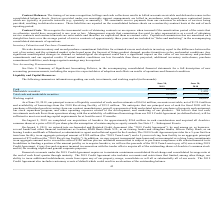From Extreme Networks's financial document, Which years does the table provide information for the company's cash, investments, and working capital? The document shows two values: 2019 and 2018. From the document: "2019 2018..." Also, What was the amount of cash in 2018? According to the financial document, 121,139 (in thousands). The relevant text states: "Cash $ 169,607 $ 121,139..." Also, What was the Total cash and marketable securities in 2019? According to the financial document, 169,607 (in thousands). The relevant text states: "Cash $ 169,607 $ 121,139..." Also, How many years did the amount of Cash exceed $100,000 thousand? Counting the relevant items in the document: 2019, 2018, I find 2 instances. The key data points involved are: 2018, 2019. Also, can you calculate: What was marketable securities as a percentage of total cash and marketable securities in 2018? Based on the calculation: 1,459/122,598, the result is 1.19 (percentage). This is based on the information: "Total cash and marketable securities $ 169,607 $ 122,598 Marketable securities — 1,459..." The key data points involved are: 1,459, 122,598. Also, can you calculate: What was the percentage change in Total cash and marketable securities between 2018 and 2019? To answer this question, I need to perform calculations using the financial data. The calculation is: (169,607-122,598)/122,598, which equals 38.34 (percentage). This is based on the information: "Total cash and marketable securities $ 169,607 $ 122,598 Cash $ 169,607 $ 121,139..." The key data points involved are: 122,598, 169,607. 